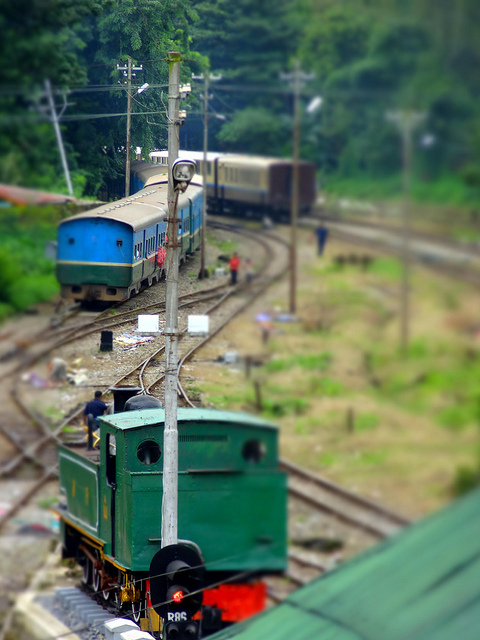Read all the text in this image. R8S 